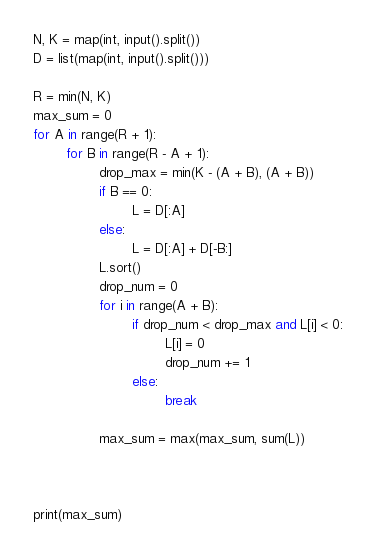<code> <loc_0><loc_0><loc_500><loc_500><_Python_>N, K = map(int, input().split())
D = list(map(int, input().split()))

R = min(N, K)
max_sum = 0
for A in range(R + 1):
        for B in range(R - A + 1):
                drop_max = min(K - (A + B), (A + B))
                if B == 0:
                        L = D[:A]
                else:
                        L = D[:A] + D[-B:]
                L.sort()
                drop_num = 0
                for i in range(A + B):
                        if drop_num < drop_max and L[i] < 0:
                                L[i] = 0
                                drop_num += 1
                        else:
                                break

                max_sum = max(max_sum, sum(L))

                

print(max_sum)</code> 